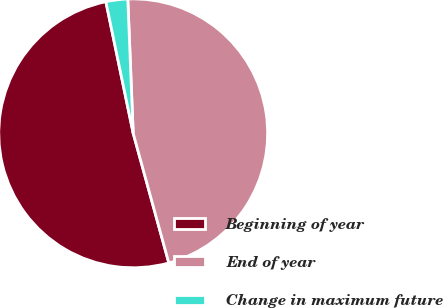Convert chart. <chart><loc_0><loc_0><loc_500><loc_500><pie_chart><fcel>Beginning of year<fcel>End of year<fcel>Change in maximum future<nl><fcel>51.01%<fcel>46.37%<fcel>2.62%<nl></chart> 